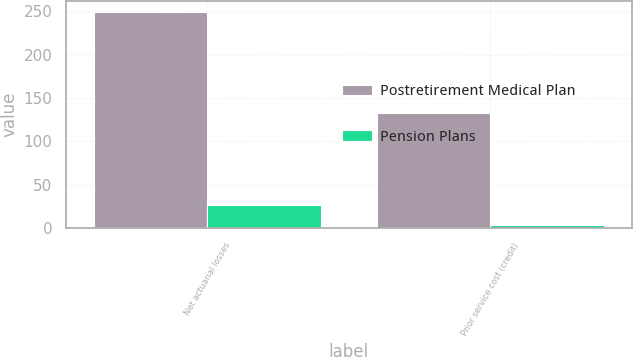Convert chart to OTSL. <chart><loc_0><loc_0><loc_500><loc_500><stacked_bar_chart><ecel><fcel>Net actuarial losses<fcel>Prior service cost (credit)<nl><fcel>Postretirement Medical Plan<fcel>249<fcel>133<nl><fcel>Pension Plans<fcel>27<fcel>4<nl></chart> 